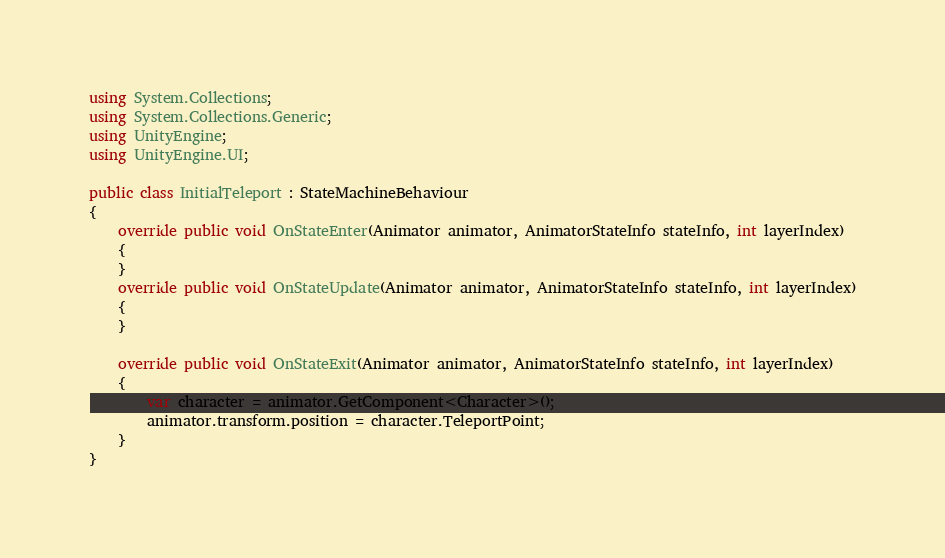<code> <loc_0><loc_0><loc_500><loc_500><_C#_>using System.Collections;
using System.Collections.Generic;
using UnityEngine;
using UnityEngine.UI;

public class InitialTeleport : StateMachineBehaviour
{
    override public void OnStateEnter(Animator animator, AnimatorStateInfo stateInfo, int layerIndex)
    {
    }
    override public void OnStateUpdate(Animator animator, AnimatorStateInfo stateInfo, int layerIndex)
    {
    }

    override public void OnStateExit(Animator animator, AnimatorStateInfo stateInfo, int layerIndex)
    {
        var character = animator.GetComponent<Character>();
        animator.transform.position = character.TeleportPoint;
    }
}
</code> 